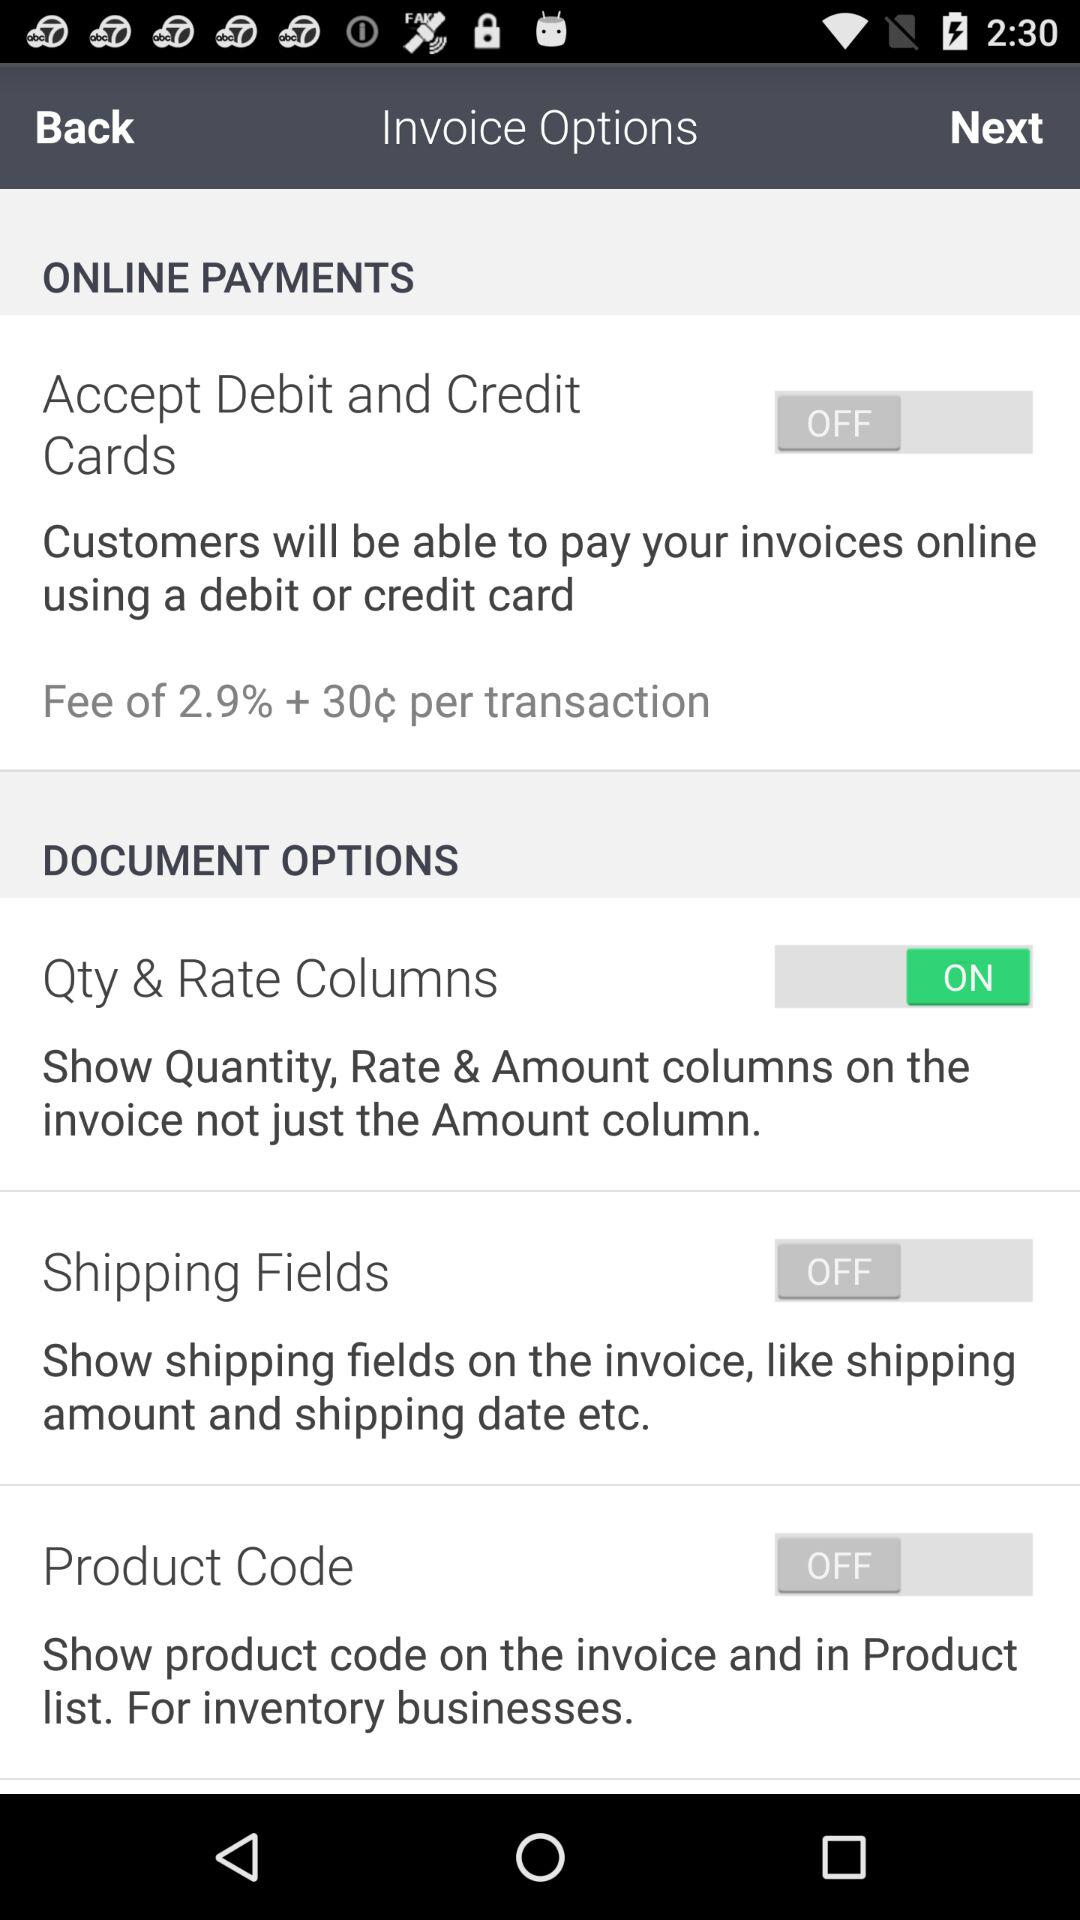What is the status of Qty & Rate Columns? The status is on. 